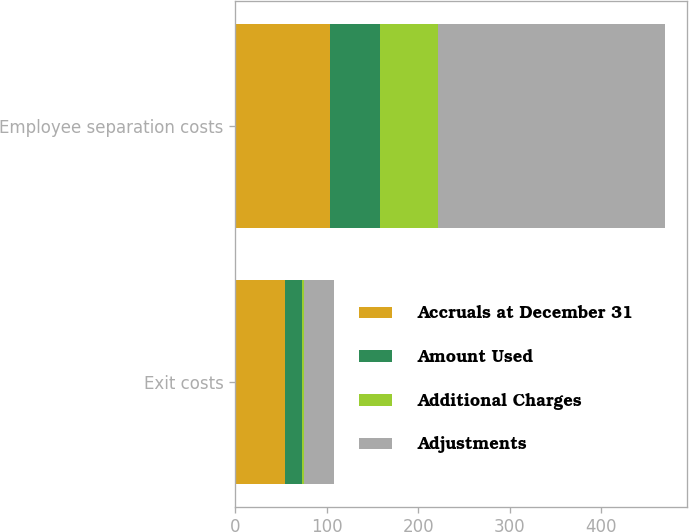<chart> <loc_0><loc_0><loc_500><loc_500><stacked_bar_chart><ecel><fcel>Exit costs<fcel>Employee separation costs<nl><fcel>Accruals at December 31<fcel>54<fcel>104<nl><fcel>Amount Used<fcel>19<fcel>54<nl><fcel>Additional Charges<fcel>2<fcel>64<nl><fcel>Adjustments<fcel>33<fcel>248<nl></chart> 